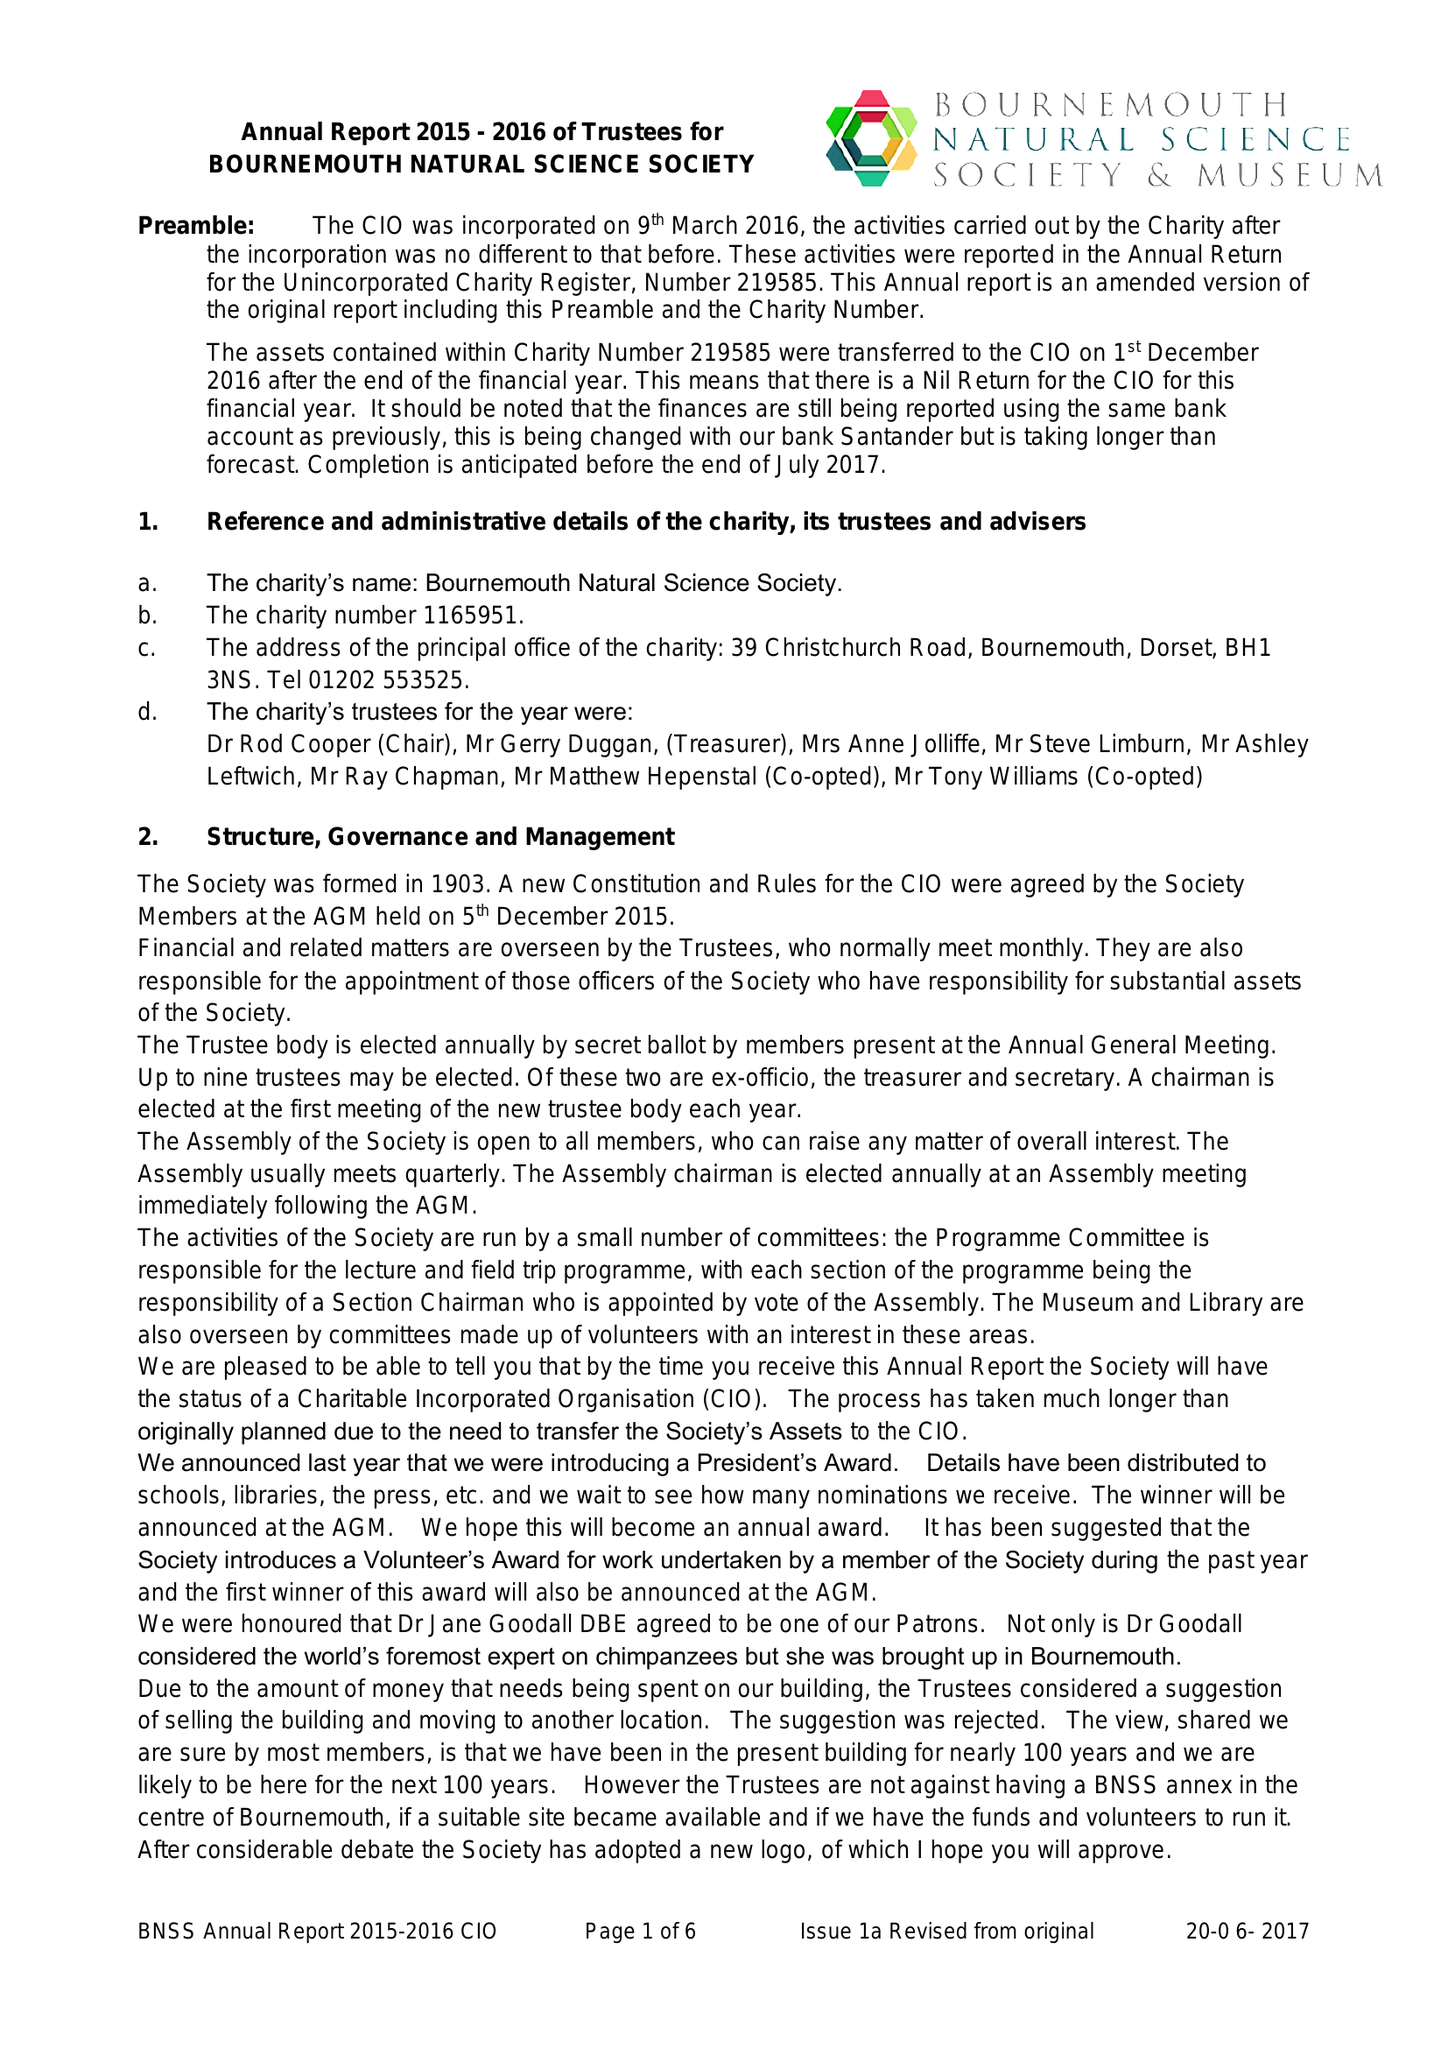What is the value for the spending_annually_in_british_pounds?
Answer the question using a single word or phrase. None 